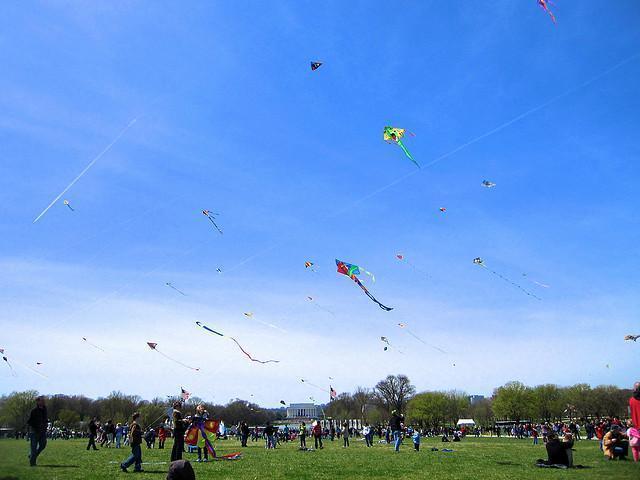How many lightbulbs are needed if two are out?
Give a very brief answer. 0. 